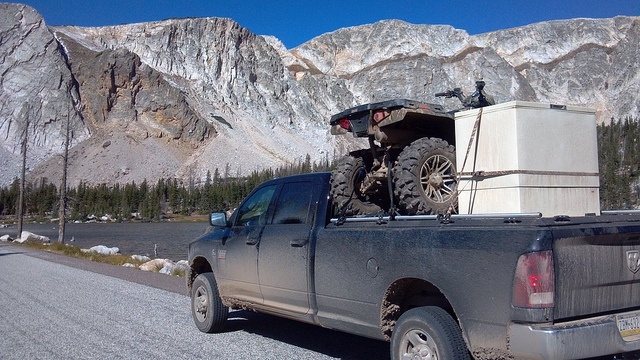Describe the objects in this image and their specific colors. I can see truck in blue, gray, black, darkgray, and lightgray tones, refrigerator in blue, lightgray, darkgray, and gray tones, and motorcycle in blue, black, gray, and darkgray tones in this image. 